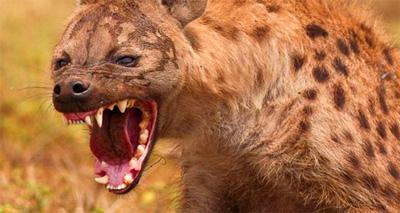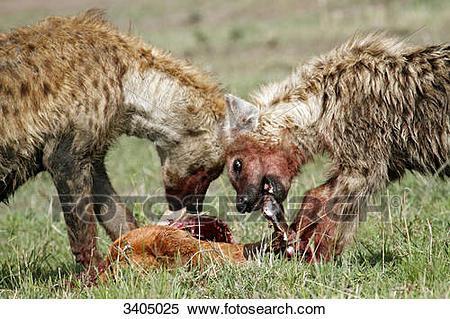The first image is the image on the left, the second image is the image on the right. For the images displayed, is the sentence "The left image includes a fang-baring hyena with wide open mouth, and the right image contains exactly two hyenas in matching poses." factually correct? Answer yes or no. Yes. The first image is the image on the left, the second image is the image on the right. Assess this claim about the two images: "The left image contains at least two hyenas.". Correct or not? Answer yes or no. No. 